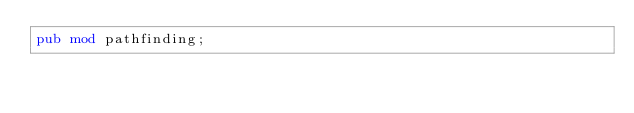Convert code to text. <code><loc_0><loc_0><loc_500><loc_500><_Rust_>pub mod pathfinding;
</code> 